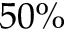Convert formula to latex. <formula><loc_0><loc_0><loc_500><loc_500>5 0 \%</formula> 